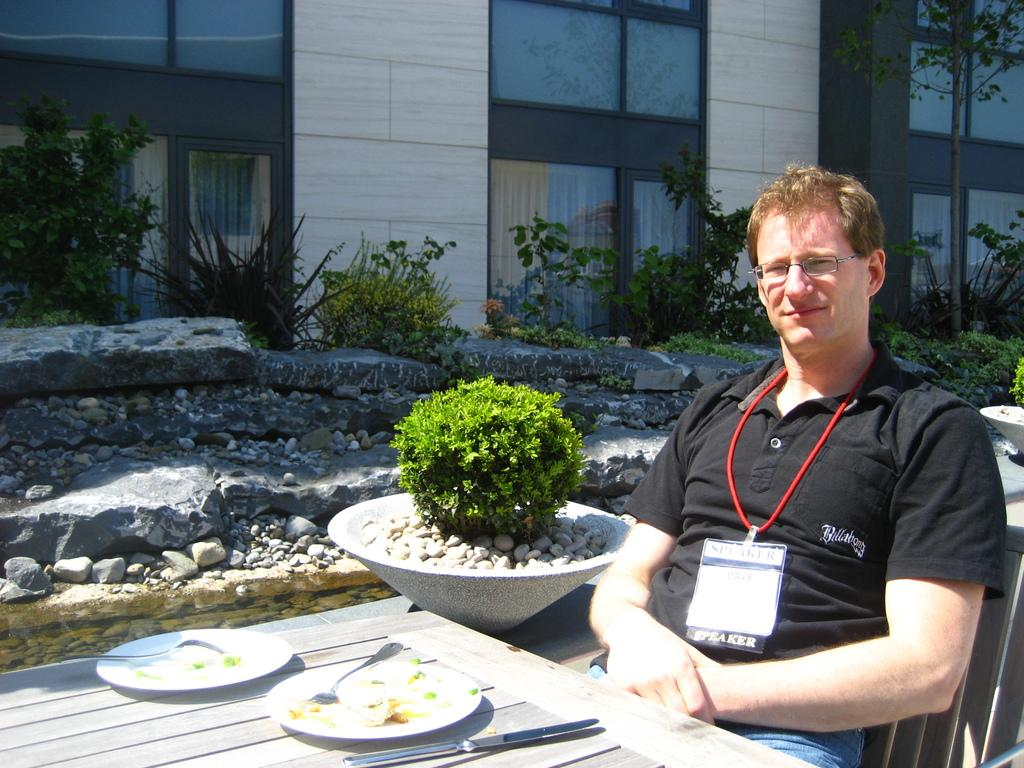Who is present in the image? There is a man in the image. What is the man doing in the image? The man is seated on a chair. What objects are on the table in front of the man? There are plates and spoons on the table in front of the man. What can be seen in the background of the image? There are plants and buildings visible in the image. What type of rake is the monkey using to open the door in the image? There is no monkey or door present in the image, and therefore no such activity can be observed. 